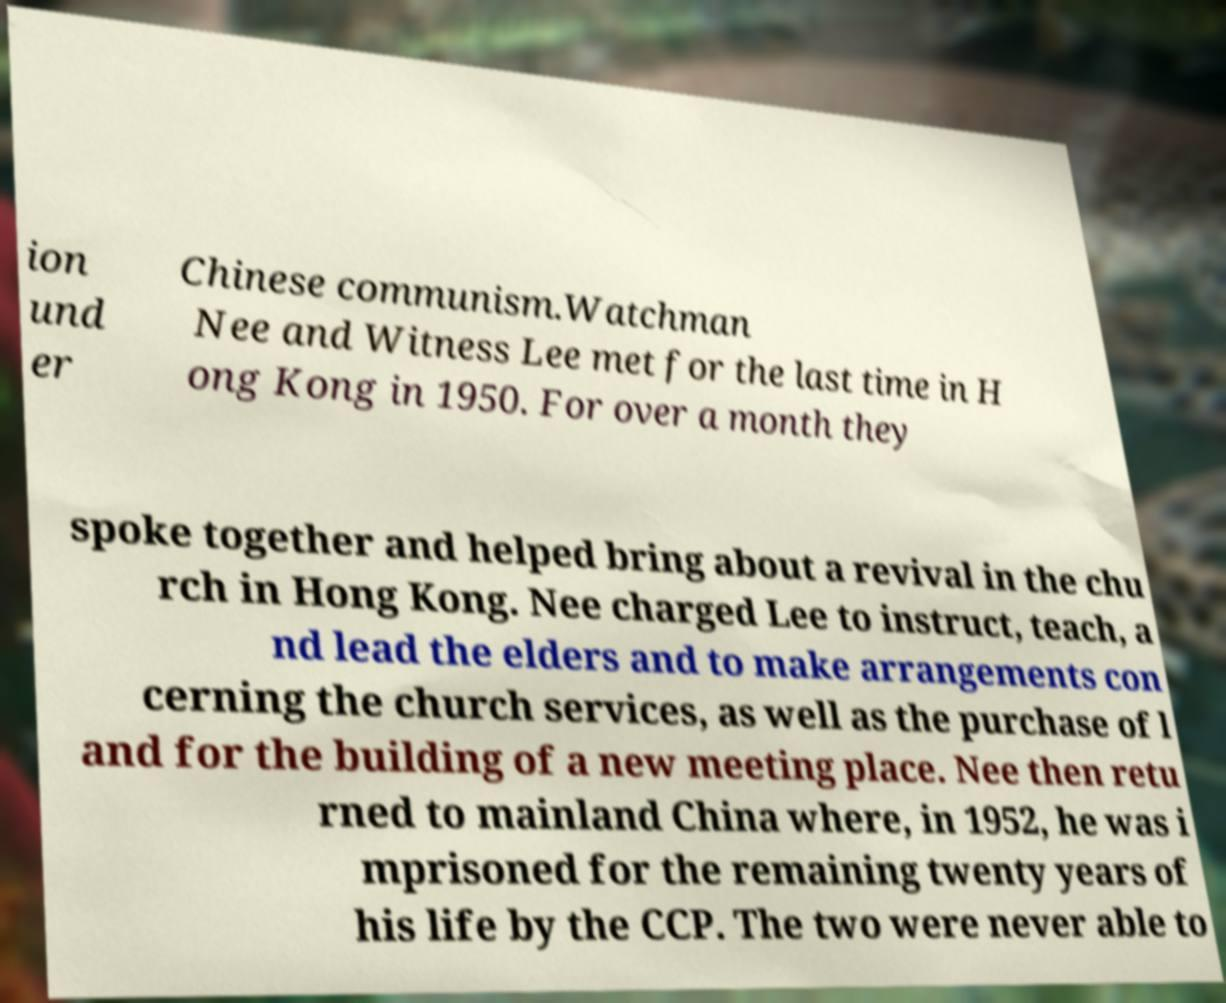Could you extract and type out the text from this image? ion und er Chinese communism.Watchman Nee and Witness Lee met for the last time in H ong Kong in 1950. For over a month they spoke together and helped bring about a revival in the chu rch in Hong Kong. Nee charged Lee to instruct, teach, a nd lead the elders and to make arrangements con cerning the church services, as well as the purchase of l and for the building of a new meeting place. Nee then retu rned to mainland China where, in 1952, he was i mprisoned for the remaining twenty years of his life by the CCP. The two were never able to 